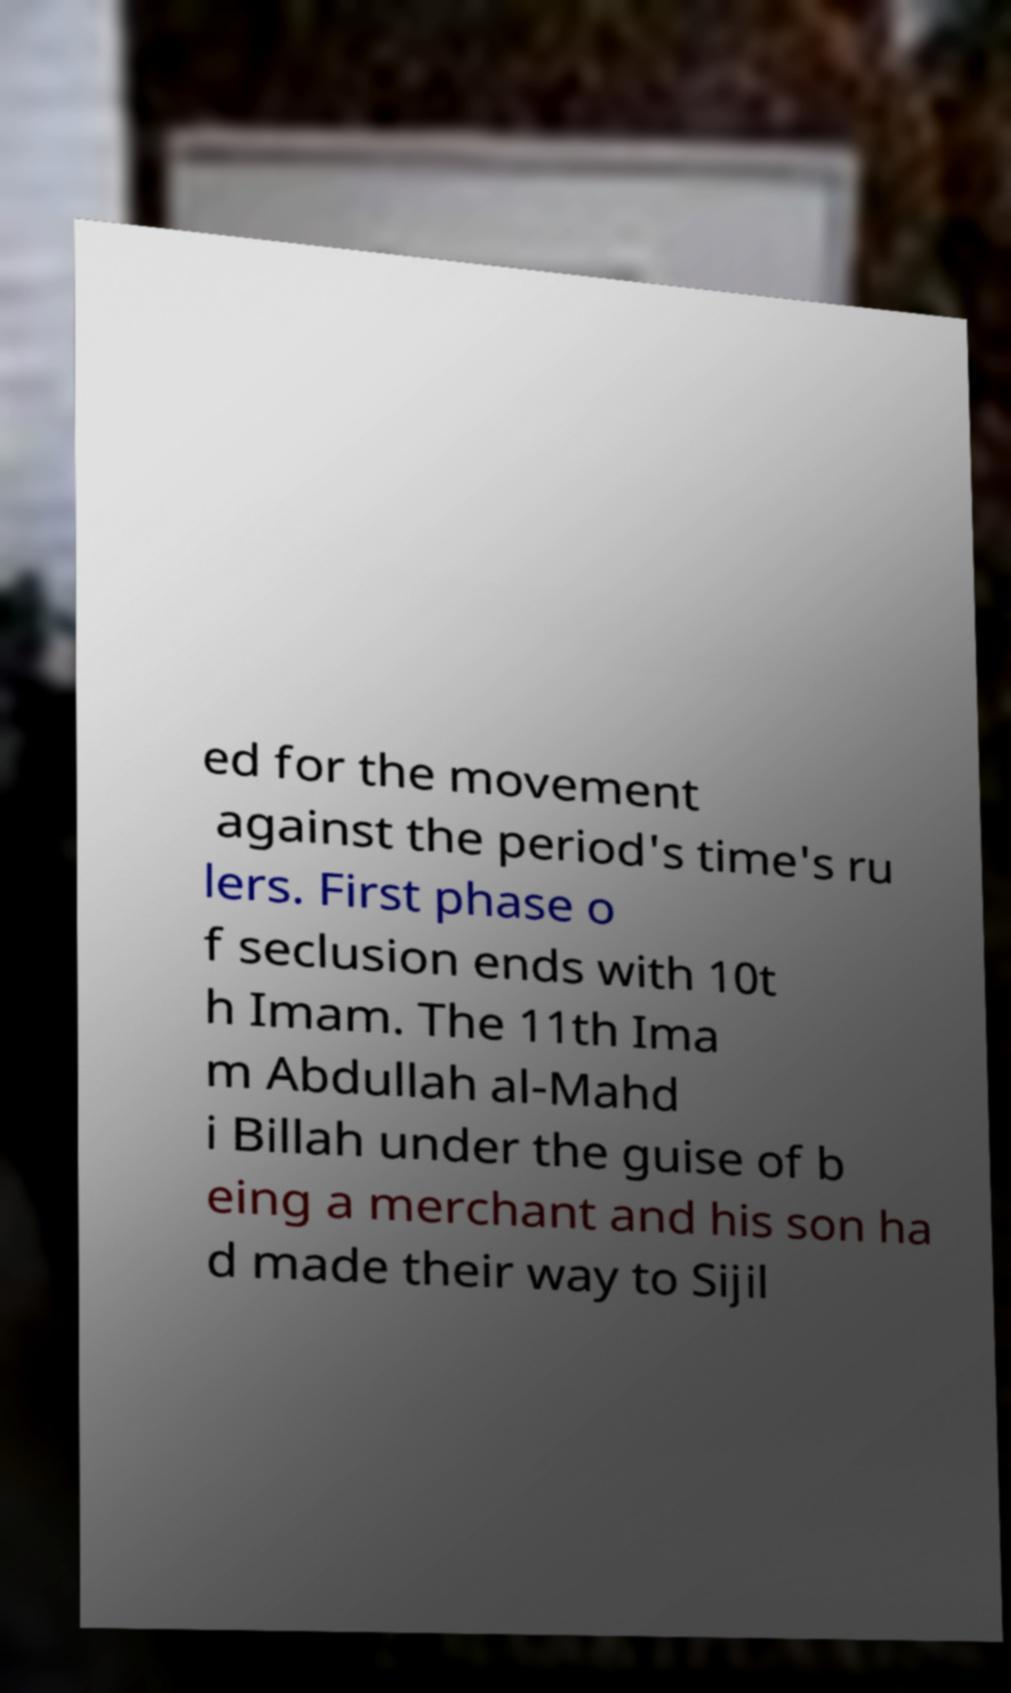Could you extract and type out the text from this image? ed for the movement against the period's time's ru lers. First phase o f seclusion ends with 10t h Imam. The 11th Ima m Abdullah al-Mahd i Billah under the guise of b eing a merchant and his son ha d made their way to Sijil 